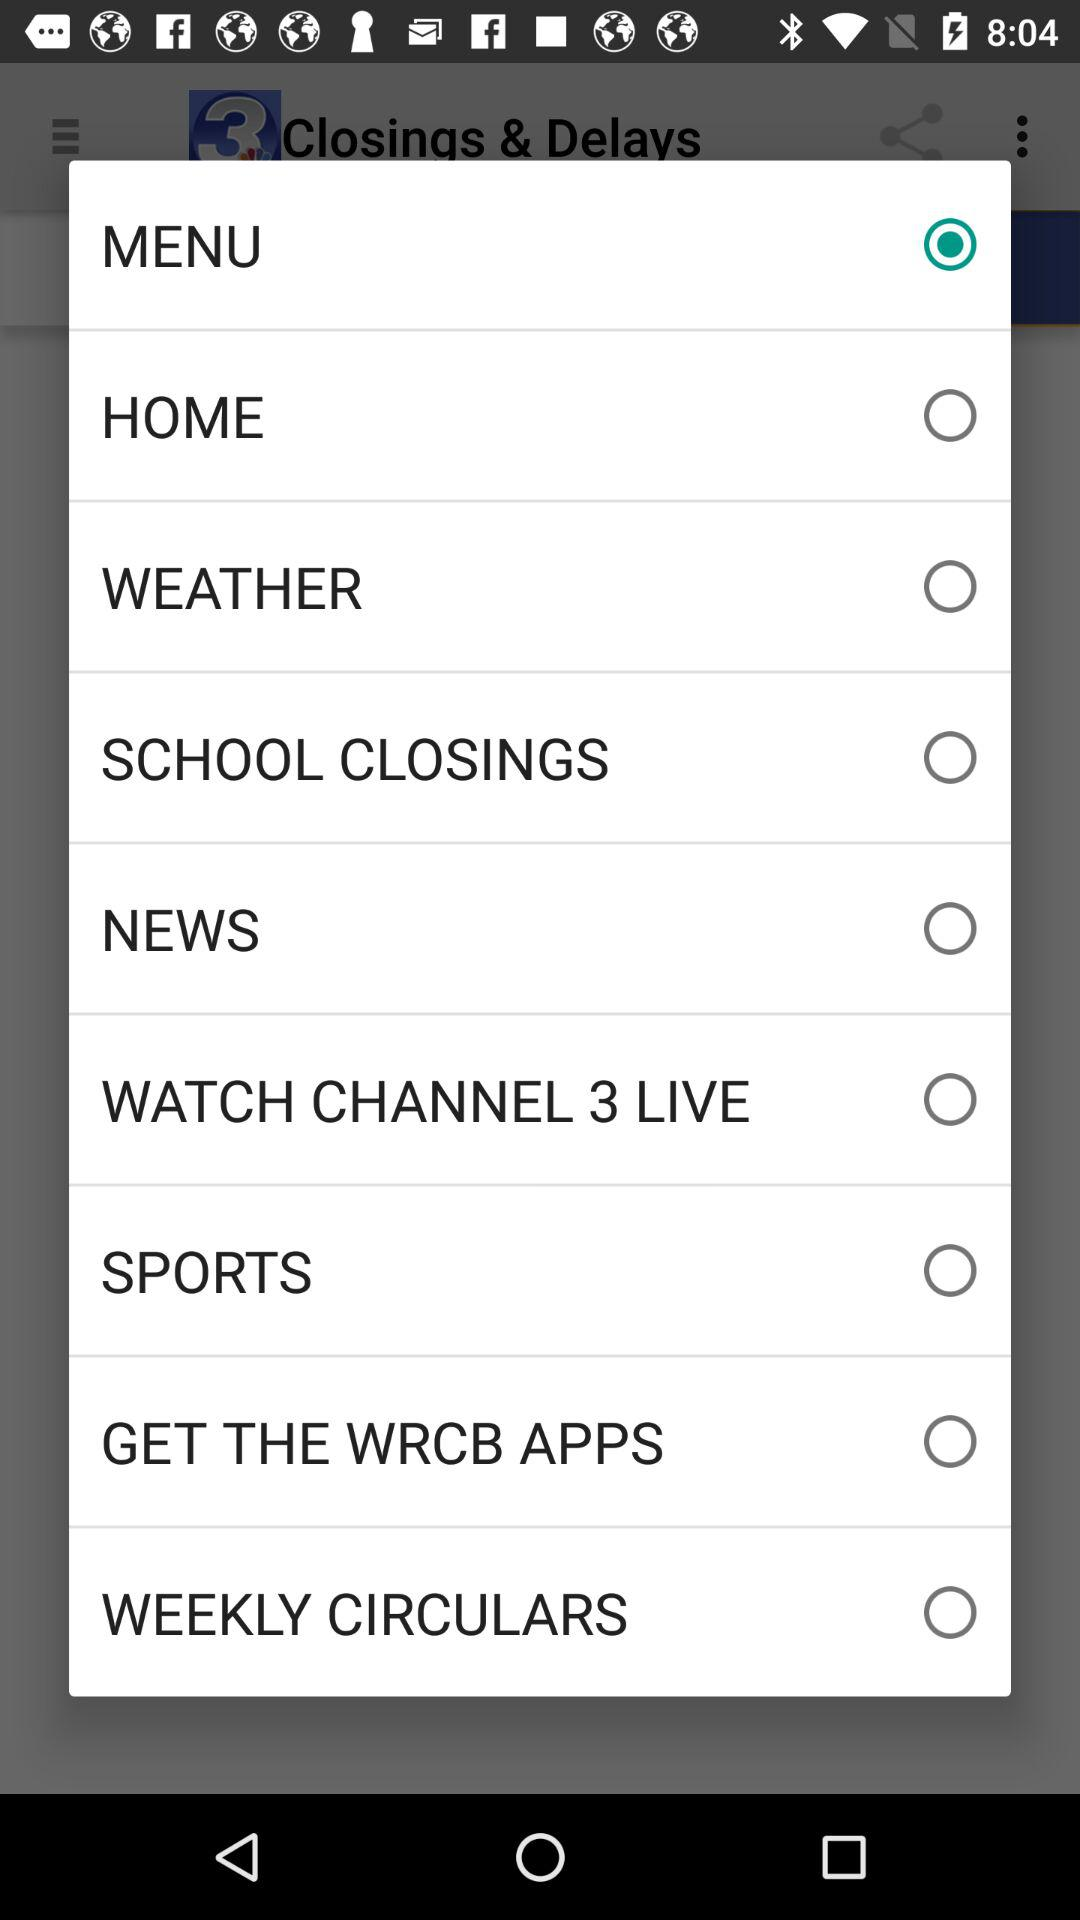What are the different options? The different options are "MENU", "HOME", "WEATHER", "SCHOOL CLOSINGS", "NEWS", "WATCH CHANNEL 3 LIVE", "SPORTS", "GET THE WRCB APPS" and "WEEKLY CIRCULARS". 